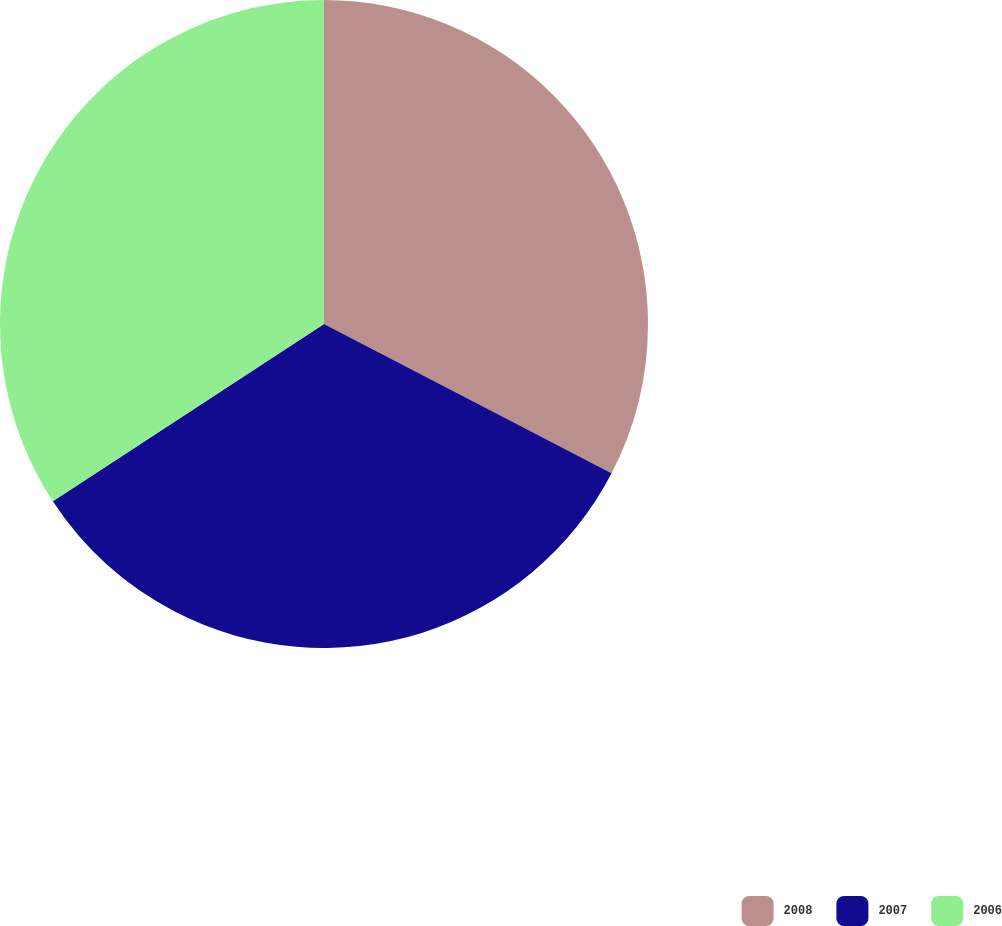<chart> <loc_0><loc_0><loc_500><loc_500><pie_chart><fcel>2008<fcel>2007<fcel>2006<nl><fcel>32.62%<fcel>33.16%<fcel>34.22%<nl></chart> 